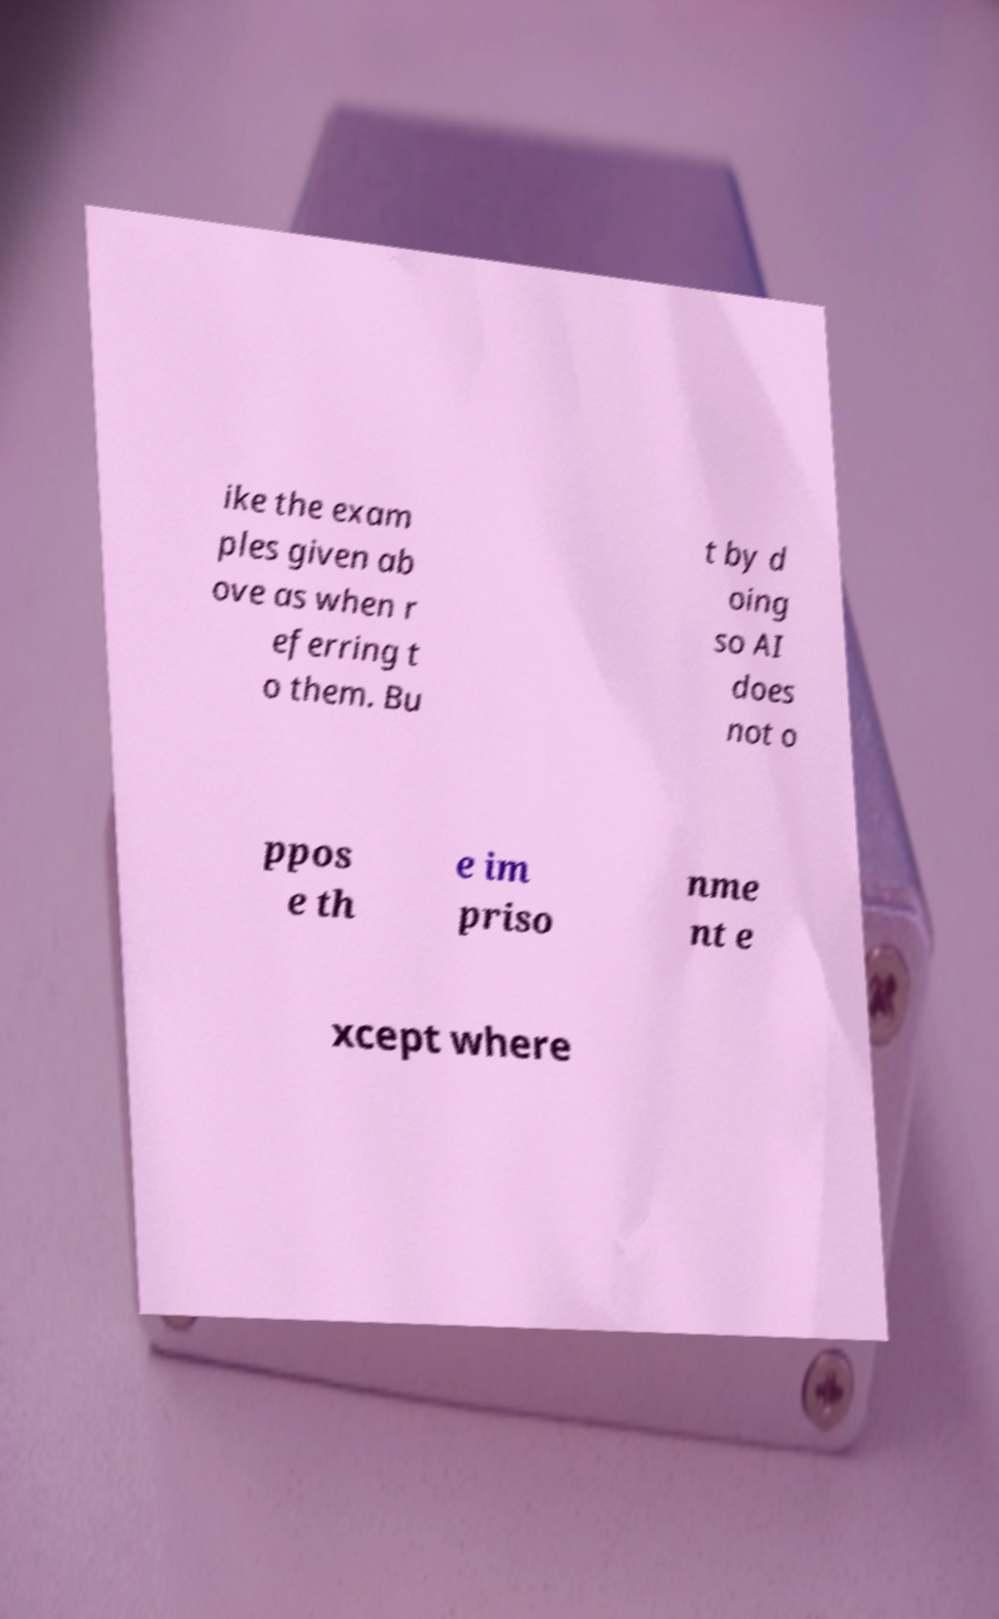I need the written content from this picture converted into text. Can you do that? ike the exam ples given ab ove as when r eferring t o them. Bu t by d oing so AI does not o ppos e th e im priso nme nt e xcept where 